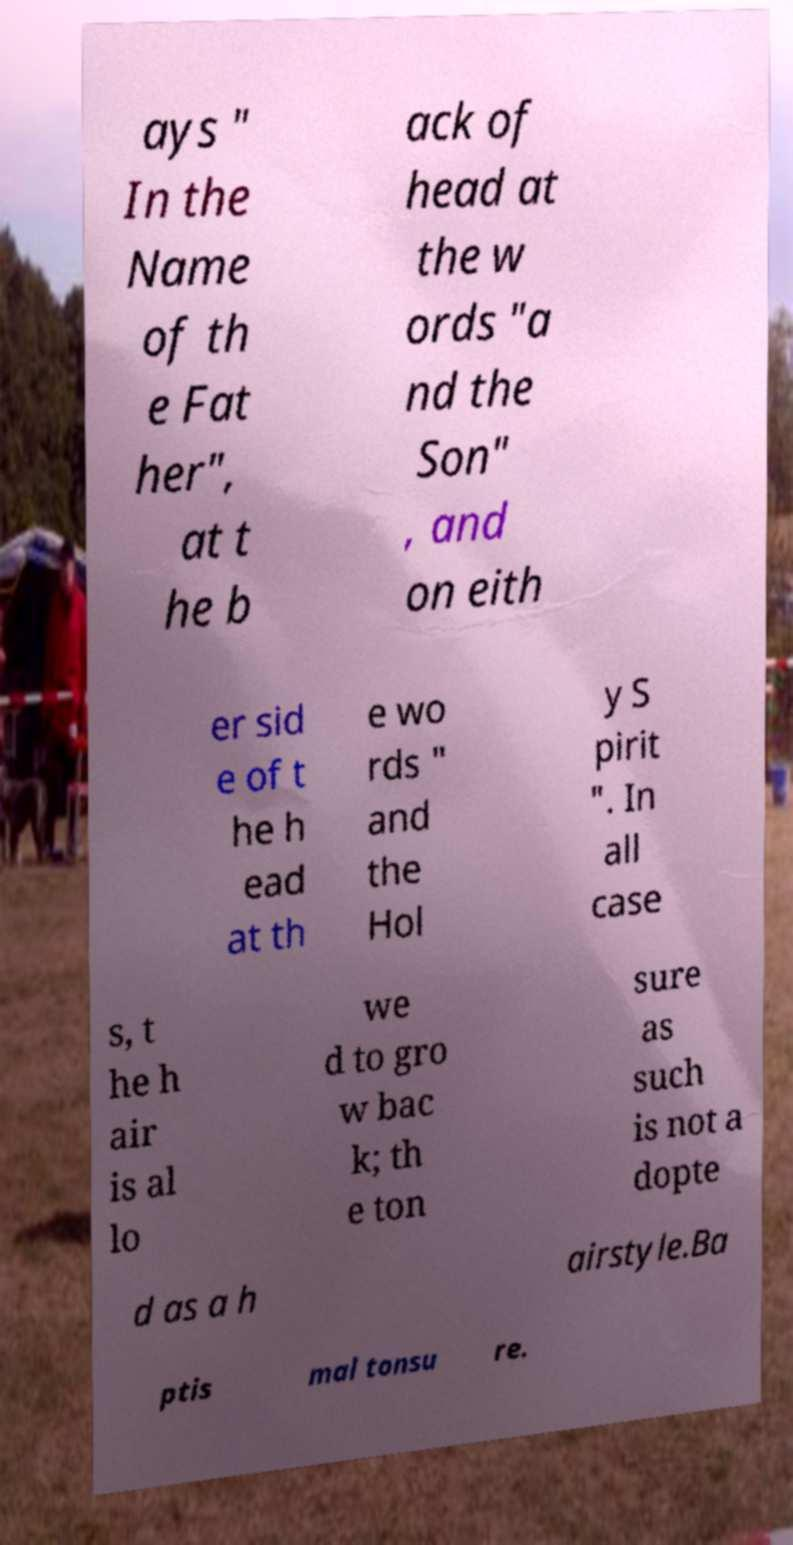Please read and relay the text visible in this image. What does it say? ays " In the Name of th e Fat her", at t he b ack of head at the w ords "a nd the Son" , and on eith er sid e of t he h ead at th e wo rds " and the Hol y S pirit ". In all case s, t he h air is al lo we d to gro w bac k; th e ton sure as such is not a dopte d as a h airstyle.Ba ptis mal tonsu re. 